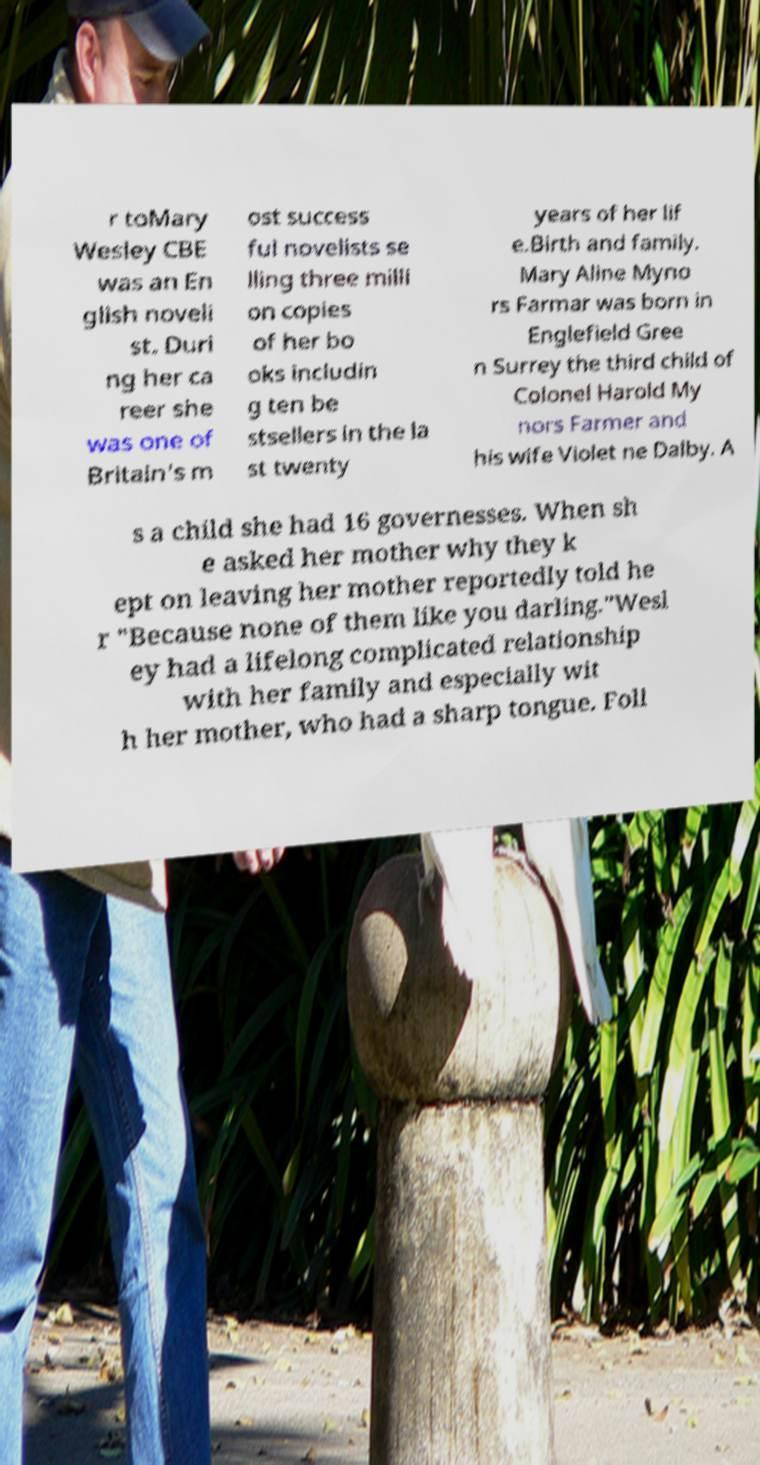Please identify and transcribe the text found in this image. r toMary Wesley CBE was an En glish noveli st. Duri ng her ca reer she was one of Britain's m ost success ful novelists se lling three milli on copies of her bo oks includin g ten be stsellers in the la st twenty years of her lif e.Birth and family. Mary Aline Myno rs Farmar was born in Englefield Gree n Surrey the third child of Colonel Harold My nors Farmer and his wife Violet ne Dalby. A s a child she had 16 governesses. When sh e asked her mother why they k ept on leaving her mother reportedly told he r "Because none of them like you darling."Wesl ey had a lifelong complicated relationship with her family and especially wit h her mother, who had a sharp tongue. Foll 